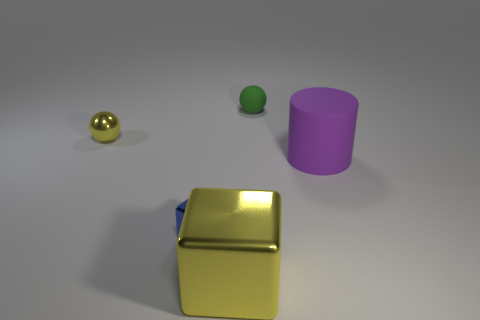Subtract 1 cubes. How many cubes are left? 1 Subtract all purple blocks. Subtract all blue cylinders. How many blocks are left? 2 Subtract all gray balls. How many yellow blocks are left? 1 Subtract all tiny gray spheres. Subtract all tiny yellow metal spheres. How many objects are left? 4 Add 3 purple rubber cylinders. How many purple rubber cylinders are left? 4 Add 3 big yellow metallic blocks. How many big yellow metallic blocks exist? 4 Add 2 blue spheres. How many objects exist? 7 Subtract 0 purple cubes. How many objects are left? 5 Subtract all blocks. How many objects are left? 3 